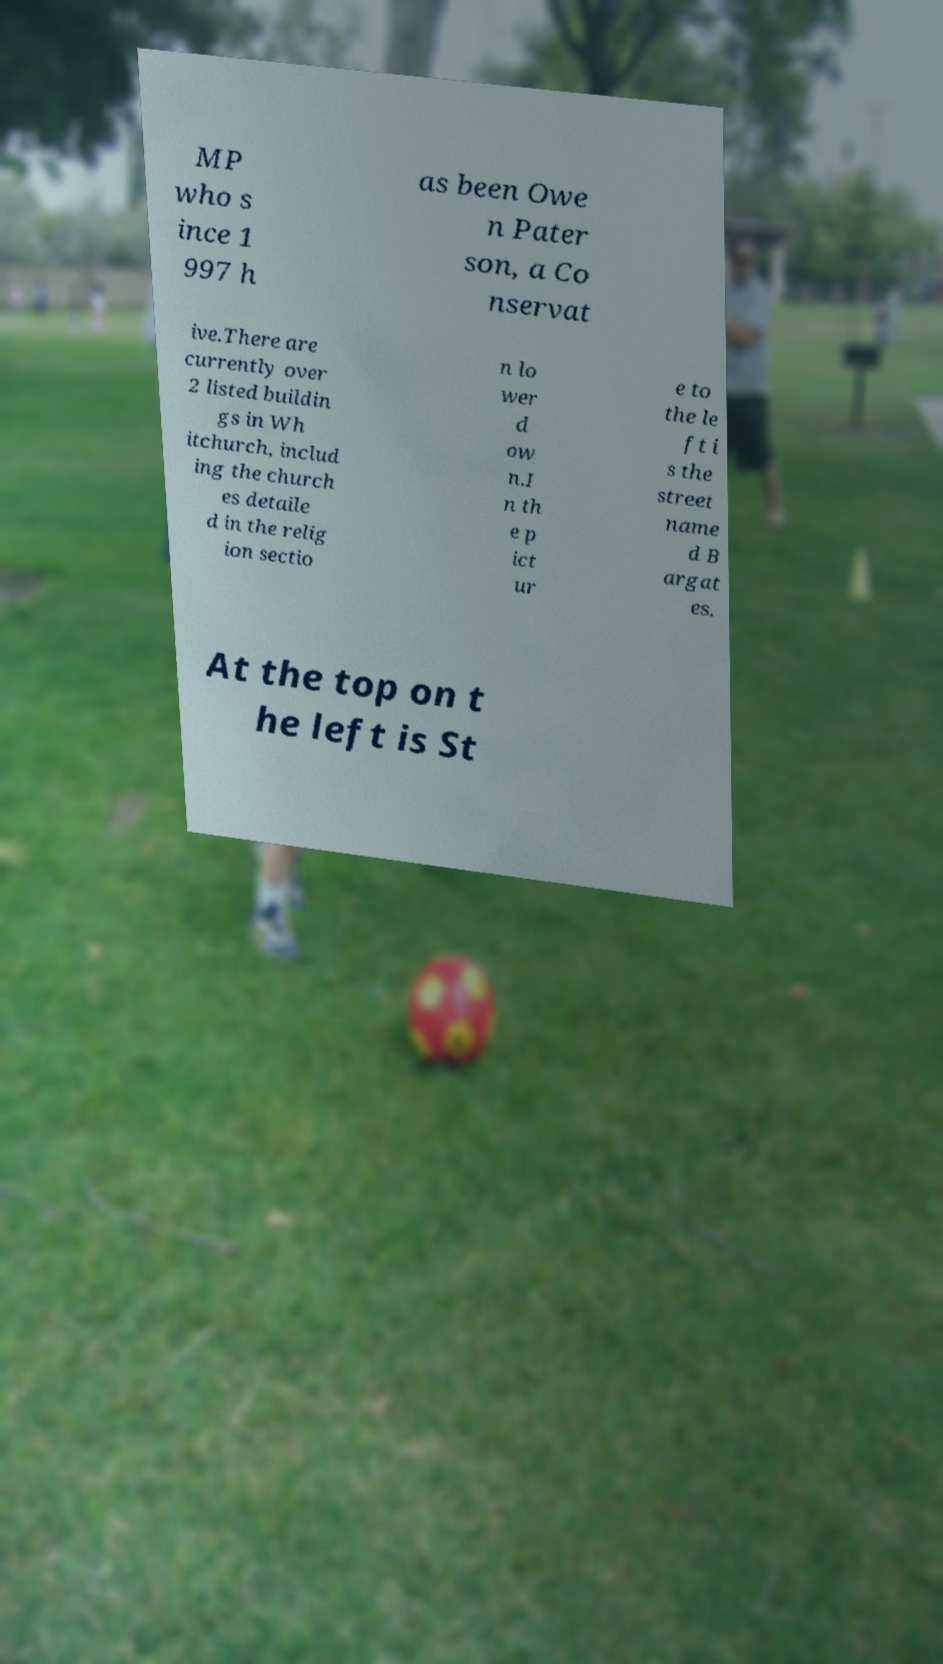Can you read and provide the text displayed in the image?This photo seems to have some interesting text. Can you extract and type it out for me? MP who s ince 1 997 h as been Owe n Pater son, a Co nservat ive.There are currently over 2 listed buildin gs in Wh itchurch, includ ing the church es detaile d in the relig ion sectio n lo wer d ow n.I n th e p ict ur e to the le ft i s the street name d B argat es. At the top on t he left is St 